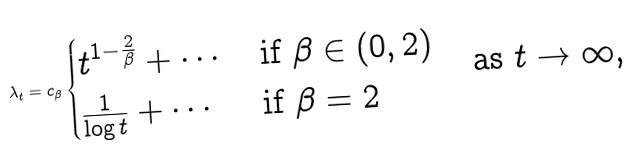<formula> <loc_0><loc_0><loc_500><loc_500>\lambda _ { t } = c _ { \beta } \begin{cases} t ^ { 1 - \frac { 2 } { \beta } } + \cdots & \text {if $\beta\in(0,2)$} \\ \frac { 1 } { \log t } + \cdots & \text {if $\beta=2$} \end{cases} \quad \text {as $t\to\infty$,}</formula> 